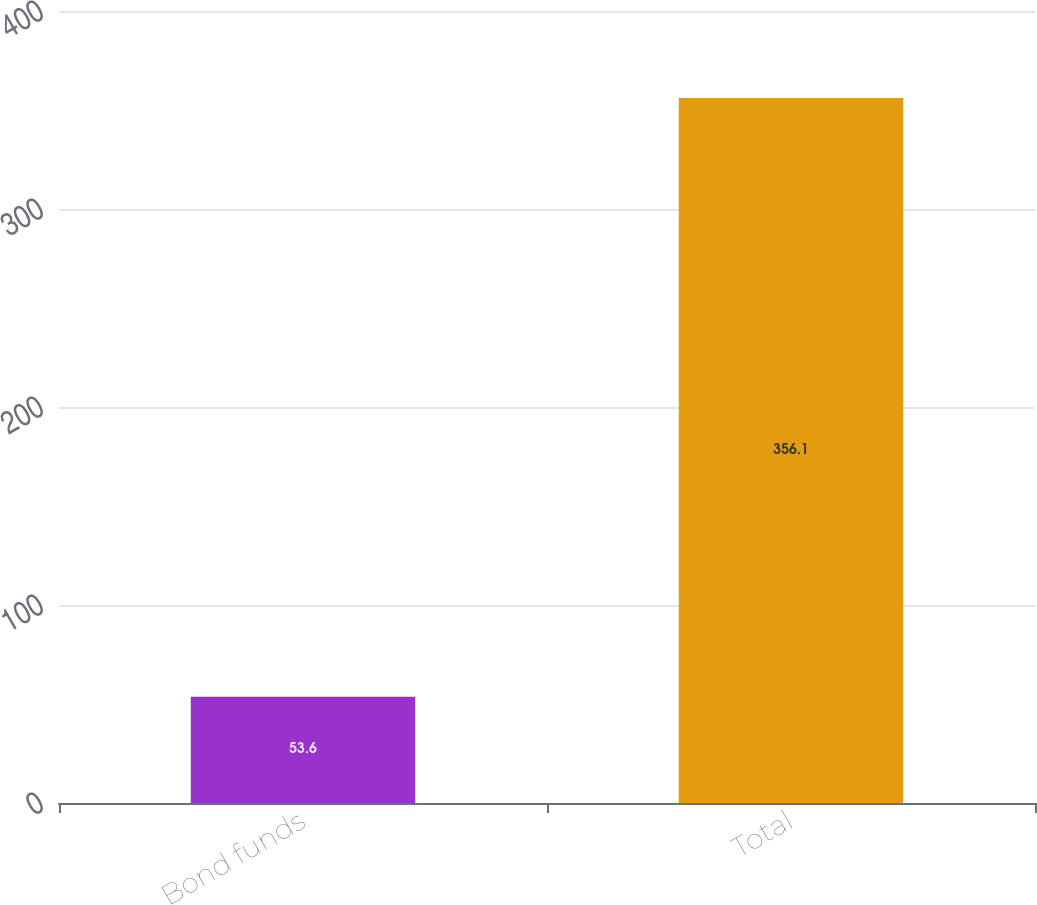Convert chart to OTSL. <chart><loc_0><loc_0><loc_500><loc_500><bar_chart><fcel>Bond funds<fcel>Total<nl><fcel>53.6<fcel>356.1<nl></chart> 